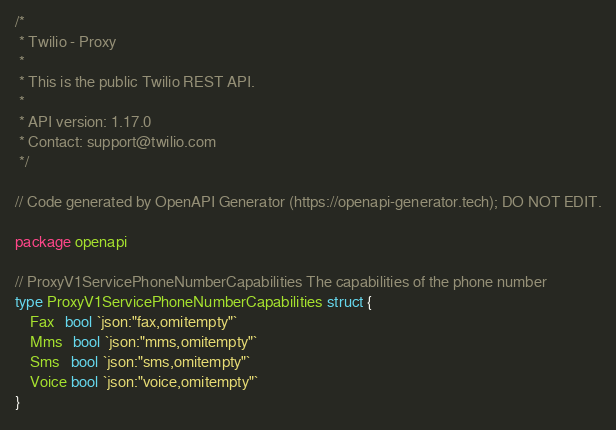<code> <loc_0><loc_0><loc_500><loc_500><_Go_>/*
 * Twilio - Proxy
 *
 * This is the public Twilio REST API.
 *
 * API version: 1.17.0
 * Contact: support@twilio.com
 */

// Code generated by OpenAPI Generator (https://openapi-generator.tech); DO NOT EDIT.

package openapi

// ProxyV1ServicePhoneNumberCapabilities The capabilities of the phone number
type ProxyV1ServicePhoneNumberCapabilities struct {
	Fax   bool `json:"fax,omitempty"`
	Mms   bool `json:"mms,omitempty"`
	Sms   bool `json:"sms,omitempty"`
	Voice bool `json:"voice,omitempty"`
}
</code> 